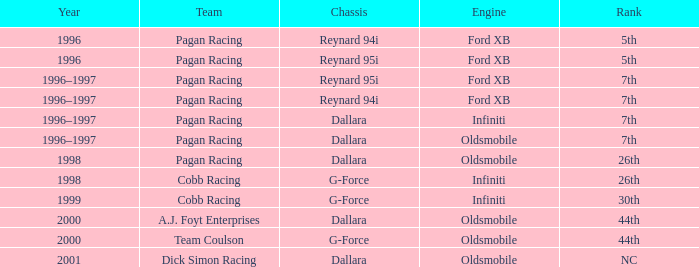What engine was employed in 1999? Infiniti. 